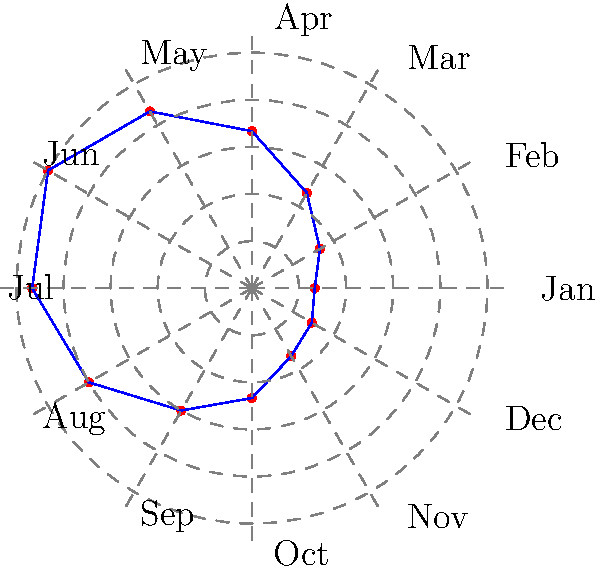In an impact evaluation study of a seasonal agricultural intervention, you've collected monthly data on crop yields throughout the year. The data is represented in the polar coordinate system shown above. What key advantage does this representation offer for analyzing cyclical patterns in the impact of the intervention? To understand the advantage of using polar coordinates for representing cyclical data in impact evaluation studies, let's consider the following steps:

1. Data Representation: In the polar coordinate system, each data point is represented by an angle (θ) and a radius (r). In this case:
   - The angle represents the month (divided into 12 equal parts around the circle)
   - The radius represents the crop yield for each month

2. Cyclical Nature: The circular representation naturally shows the cyclical pattern of the data over a year. January (month 1) and December (month 12) are adjacent, reflecting the continuous nature of yearly cycles.

3. Pattern Visualization: The blue line connecting the data points forms a shape that repeats annually. This makes it easy to identify:
   - Seasonal peaks (longest radii)
   - Seasonal troughs (shortest radii)
   - Rate of change between seasons (steepness of the line)

4. Comparison Across Years: If multiple years of data were plotted, they could be easily overlaid to compare patterns and detect changes in the intervention's impact over time.

5. Intervention Analysis: The shape of the pattern can reveal:
   - When the intervention has the most significant impact (peaks)
   - When it might need adjustment (troughs)
   - How the impact changes throughout the year

6. Continuous Flow: Unlike a linear graph where December and January are at opposite ends, this representation shows the continuous flow of time and impact, which is crucial for agricultural cycles.

7. Anomaly Detection: Any unusual spikes or dips in the pattern are easily noticeable, allowing for quick identification of anomalies in the intervention's impact.

The key advantage of this representation is that it allows for intuitive visualization and analysis of cyclical patterns in the intervention's impact, making it easier to identify seasonal trends, compare across cycles, and make data-driven decisions for optimizing the agricultural intervention.
Answer: Intuitive visualization of cyclical patterns and seasonal trends 